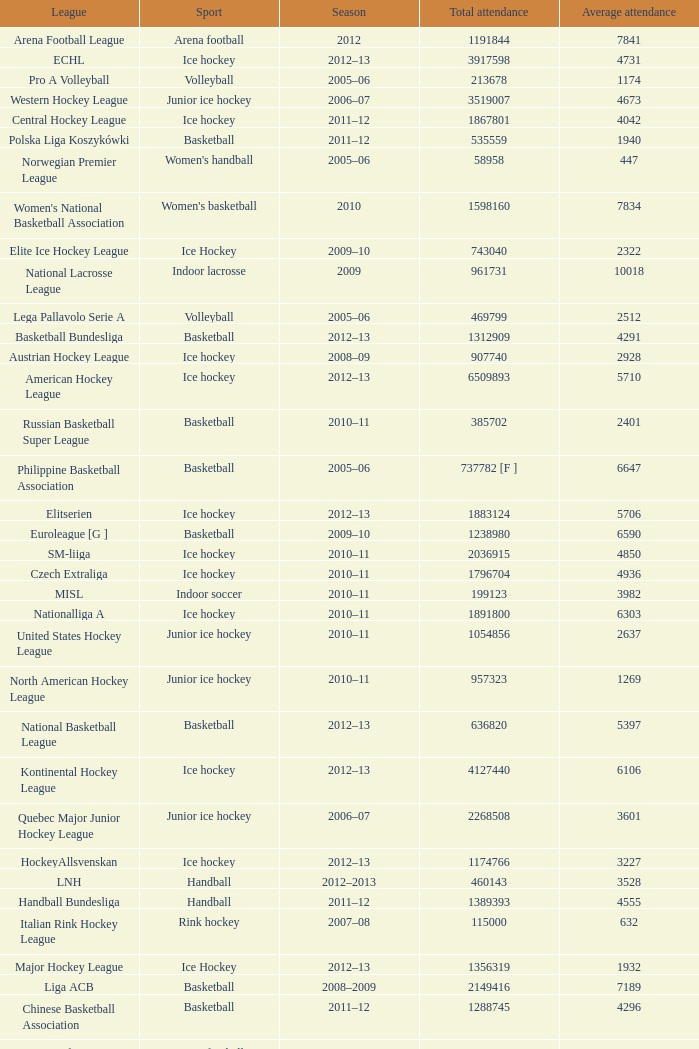What's the total attendance in rink hockey when the average attendance was smaller than 4850? 115000.0. 